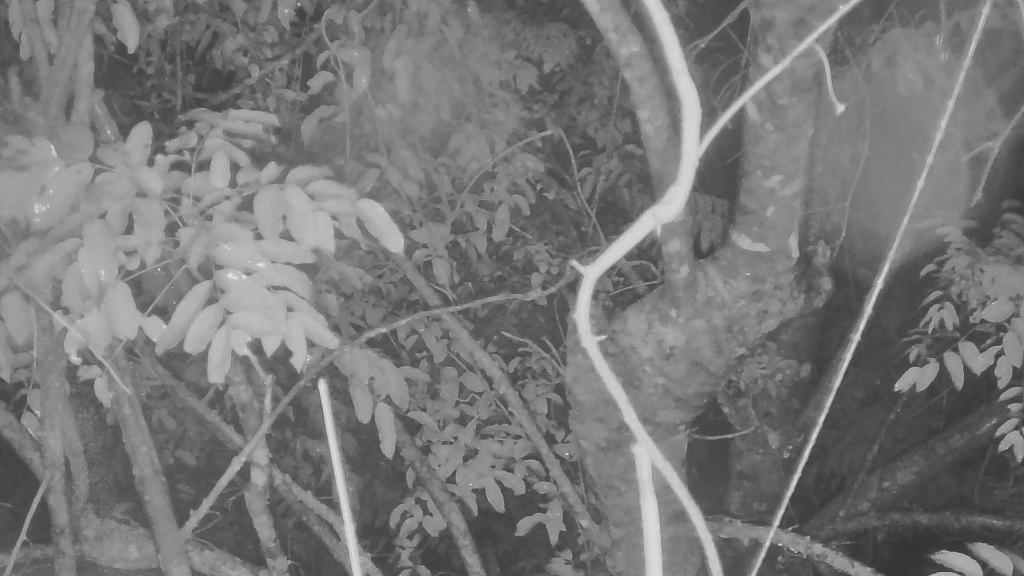What is the color scheme of the image? The image is black and white. What type of natural elements can be seen in the image? There are branches of trees in the image. What is present on the branches of the trees? The branches have leaves. How does the division of the branches affect the growth of the kitten in the image? There is no kitten present in the image, and therefore no such interaction can be observed. 